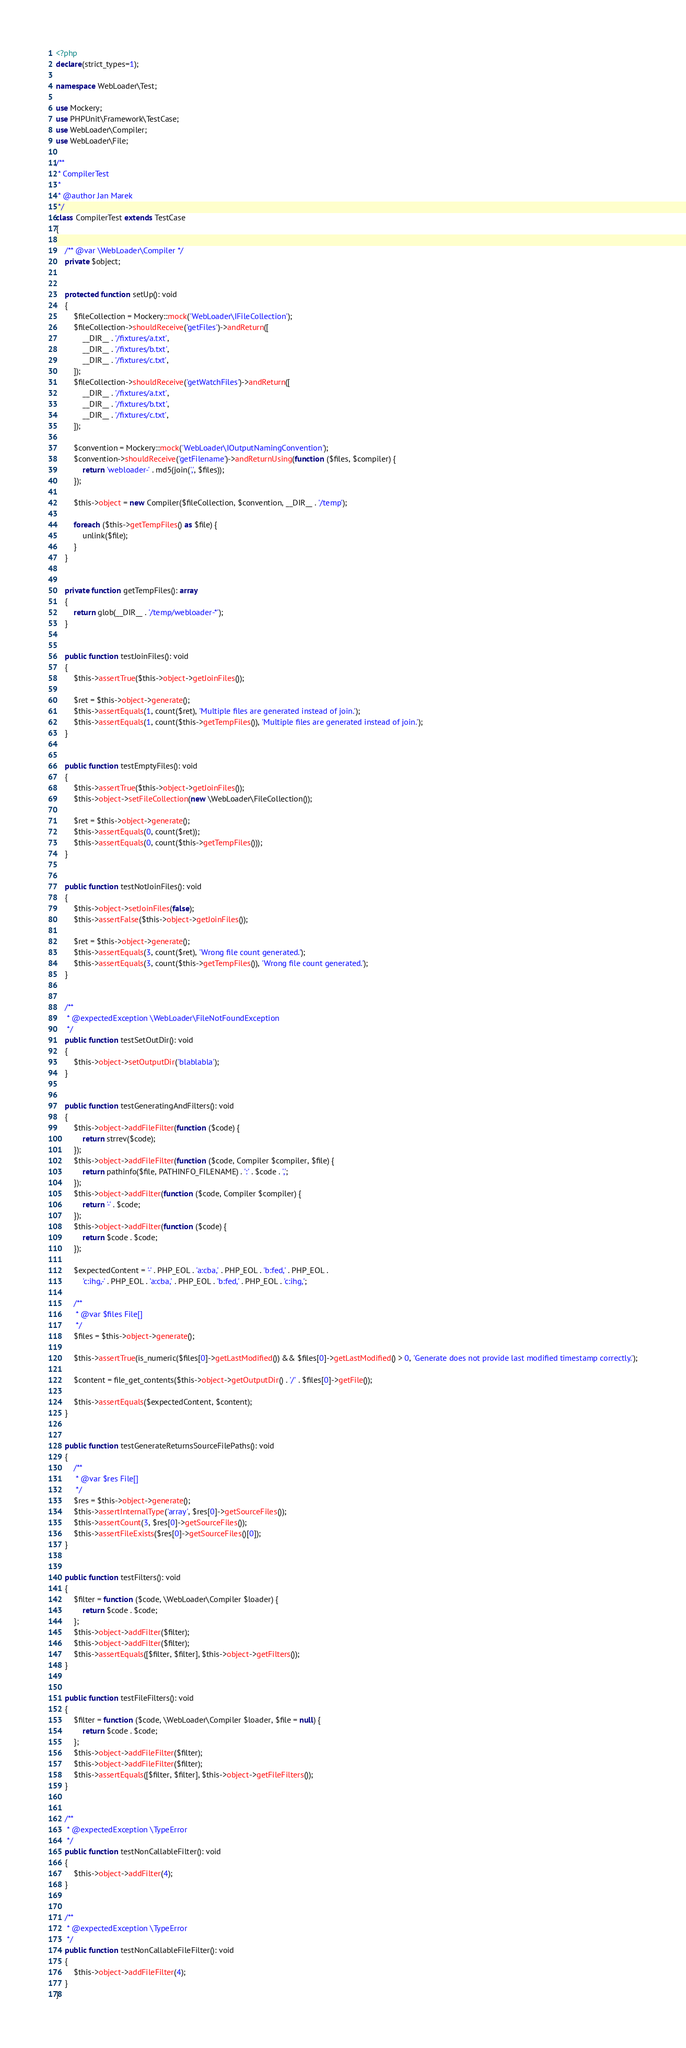<code> <loc_0><loc_0><loc_500><loc_500><_PHP_><?php
declare(strict_types=1);

namespace WebLoader\Test;

use Mockery;
use PHPUnit\Framework\TestCase;
use WebLoader\Compiler;
use WebLoader\File;

/**
 * CompilerTest
 *
 * @author Jan Marek
 */
class CompilerTest extends TestCase
{

	/** @var \WebLoader\Compiler */
	private $object;


	protected function setUp(): void
	{
		$fileCollection = Mockery::mock('WebLoader\IFileCollection');
		$fileCollection->shouldReceive('getFiles')->andReturn([
			__DIR__ . '/fixtures/a.txt',
			__DIR__ . '/fixtures/b.txt',
			__DIR__ . '/fixtures/c.txt',
		]);
		$fileCollection->shouldReceive('getWatchFiles')->andReturn([
			__DIR__ . '/fixtures/a.txt',
			__DIR__ . '/fixtures/b.txt',
			__DIR__ . '/fixtures/c.txt',
		]);

		$convention = Mockery::mock('WebLoader\IOutputNamingConvention');
		$convention->shouldReceive('getFilename')->andReturnUsing(function ($files, $compiler) {
			return 'webloader-' . md5(join(',', $files));
		});

		$this->object = new Compiler($fileCollection, $convention, __DIR__ . '/temp');

		foreach ($this->getTempFiles() as $file) {
			unlink($file);
		}
	}


	private function getTempFiles(): array
	{
		return glob(__DIR__ . '/temp/webloader-*');
	}


	public function testJoinFiles(): void
	{
		$this->assertTrue($this->object->getJoinFiles());

		$ret = $this->object->generate();
		$this->assertEquals(1, count($ret), 'Multiple files are generated instead of join.');
		$this->assertEquals(1, count($this->getTempFiles()), 'Multiple files are generated instead of join.');
	}


	public function testEmptyFiles(): void
	{
		$this->assertTrue($this->object->getJoinFiles());
		$this->object->setFileCollection(new \WebLoader\FileCollection());

		$ret = $this->object->generate();
		$this->assertEquals(0, count($ret));
		$this->assertEquals(0, count($this->getTempFiles()));
	}


	public function testNotJoinFiles(): void
	{
		$this->object->setJoinFiles(false);
		$this->assertFalse($this->object->getJoinFiles());

		$ret = $this->object->generate();
		$this->assertEquals(3, count($ret), 'Wrong file count generated.');
		$this->assertEquals(3, count($this->getTempFiles()), 'Wrong file count generated.');
	}


	/**
	 * @expectedException \WebLoader\FileNotFoundException
	 */
	public function testSetOutDir(): void
	{
		$this->object->setOutputDir('blablabla');
	}


	public function testGeneratingAndFilters(): void
	{
		$this->object->addFileFilter(function ($code) {
			return strrev($code);
		});
		$this->object->addFileFilter(function ($code, Compiler $compiler, $file) {
			return pathinfo($file, PATHINFO_FILENAME) . ':' . $code . ',';
		});
		$this->object->addFilter(function ($code, Compiler $compiler) {
			return '-' . $code;
		});
		$this->object->addFilter(function ($code) {
			return $code . $code;
		});

		$expectedContent = '-' . PHP_EOL . 'a:cba,' . PHP_EOL . 'b:fed,' . PHP_EOL .
			'c:ihg,-' . PHP_EOL . 'a:cba,' . PHP_EOL . 'b:fed,' . PHP_EOL . 'c:ihg,';

		/**
		 * @var $files File[]
		 */
		$files = $this->object->generate();

		$this->assertTrue(is_numeric($files[0]->getLastModified()) && $files[0]->getLastModified() > 0, 'Generate does not provide last modified timestamp correctly.');

		$content = file_get_contents($this->object->getOutputDir() . '/' . $files[0]->getFile());

		$this->assertEquals($expectedContent, $content);
	}


	public function testGenerateReturnsSourceFilePaths(): void
	{
		/**
		 * @var $res File[]
		 */
		$res = $this->object->generate();
		$this->assertInternalType('array', $res[0]->getSourceFiles());
		$this->assertCount(3, $res[0]->getSourceFiles());
		$this->assertFileExists($res[0]->getSourceFiles()[0]);
	}


	public function testFilters(): void
	{
		$filter = function ($code, \WebLoader\Compiler $loader) {
			return $code . $code;
		};
		$this->object->addFilter($filter);
		$this->object->addFilter($filter);
		$this->assertEquals([$filter, $filter], $this->object->getFilters());
	}


	public function testFileFilters(): void
	{
		$filter = function ($code, \WebLoader\Compiler $loader, $file = null) {
			return $code . $code;
		};
		$this->object->addFileFilter($filter);
		$this->object->addFileFilter($filter);
		$this->assertEquals([$filter, $filter], $this->object->getFileFilters());
	}


	/**
	 * @expectedException \TypeError
	 */
	public function testNonCallableFilter(): void
	{
		$this->object->addFilter(4);
	}


	/**
	 * @expectedException \TypeError
	 */
	public function testNonCallableFileFilter(): void
	{
		$this->object->addFileFilter(4);
	}
}
</code> 